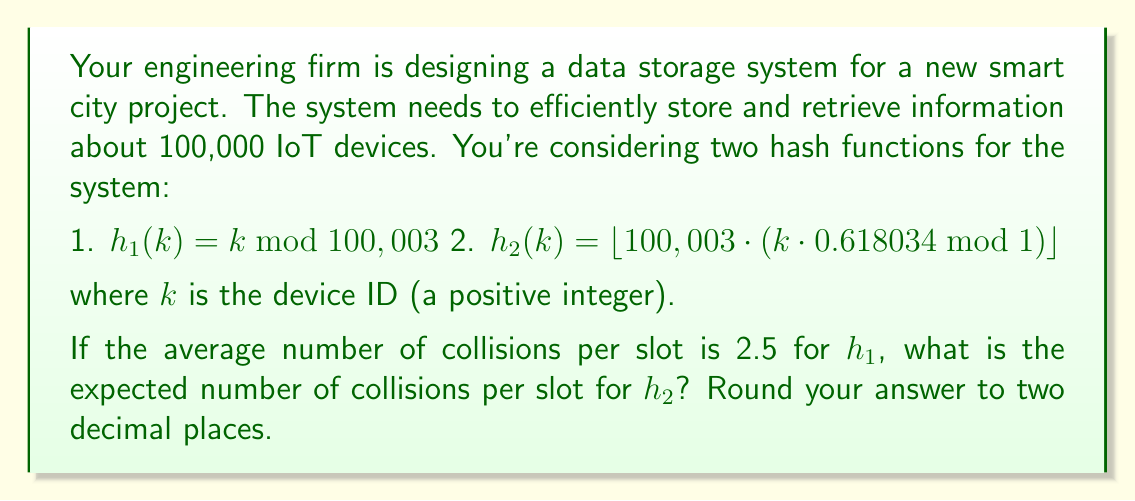Show me your answer to this math problem. To solve this problem, we need to understand how hash functions and load factors work in data storage systems:

1) The load factor $\alpha$ is defined as:

   $\alpha = \frac{n}{m}$

   where $n$ is the number of items to be stored, and $m$ is the number of slots in the hash table.

2) For $h_1$, we have:
   $m_1 = 100,003$ (the modulus used in $h_1$)
   $n = 100,000$ (the number of IoT devices)

   So, $\alpha_1 = \frac{100,000}{100,003} \approx 0.99997$

3) We're told that the average number of collisions per slot for $h_1$ is 2.5. This means that on average, each slot contains 3.5 items (2.5 collisions + 1 original item).

4) For a good hash function, the number of items per slot should follow a Poisson distribution with mean $\lambda = \alpha$. In this case:

   $3.5 = e^{\lambda_1} = e^{\alpha_1}$

   $\lambda_1 = \ln(3.5) \approx 1.2528$

5) The fact that $\lambda_1 \neq \alpha_1$ suggests that $h_1$ is not an ideal hash function.

6) Now, let's consider $h_2$. This function uses the multiplication method with the golden ratio ($0.618034...$), which is known to produce a more uniform distribution.

7) For $h_2$, we have the same number of slots: $m_2 = 100,003$

8) Assuming $h_2$ is a good hash function, we expect:

   $\lambda_2 = \alpha_2 = \frac{100,000}{100,003} \approx 0.99997$

9) For a Poisson distribution, the expected number of collisions is:

   $E(\text{collisions}) = \lambda - (1 - e^{-\lambda})$

10) Plugging in $\lambda_2$:

    $E(\text{collisions}) = 0.99997 - (1 - e^{-0.99997}) \approx 0.4323$

Therefore, we expect about 0.43 collisions per slot for $h_2$.
Answer: 0.43 